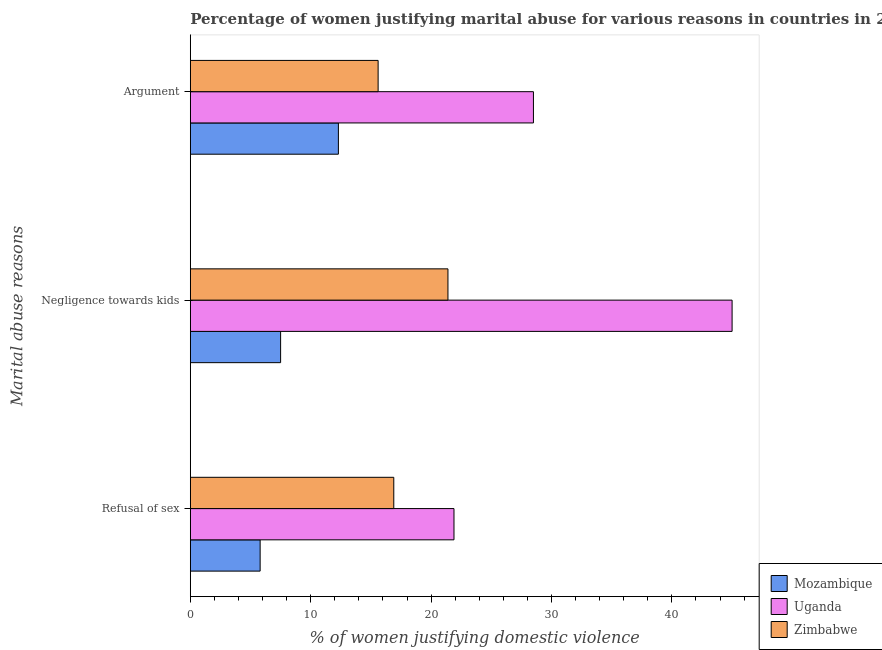Are the number of bars per tick equal to the number of legend labels?
Make the answer very short. Yes. Are the number of bars on each tick of the Y-axis equal?
Your answer should be compact. Yes. How many bars are there on the 3rd tick from the top?
Offer a terse response. 3. How many bars are there on the 3rd tick from the bottom?
Give a very brief answer. 3. What is the label of the 3rd group of bars from the top?
Ensure brevity in your answer.  Refusal of sex. In which country was the percentage of women justifying domestic violence due to refusal of sex maximum?
Your response must be concise. Uganda. In which country was the percentage of women justifying domestic violence due to negligence towards kids minimum?
Your answer should be compact. Mozambique. What is the total percentage of women justifying domestic violence due to arguments in the graph?
Make the answer very short. 56.4. What is the difference between the percentage of women justifying domestic violence due to refusal of sex in Zimbabwe and that in Mozambique?
Offer a very short reply. 11.1. What is the difference between the percentage of women justifying domestic violence due to negligence towards kids in Mozambique and the percentage of women justifying domestic violence due to refusal of sex in Zimbabwe?
Make the answer very short. -9.4. What is the average percentage of women justifying domestic violence due to refusal of sex per country?
Your response must be concise. 14.87. What is the difference between the percentage of women justifying domestic violence due to arguments and percentage of women justifying domestic violence due to refusal of sex in Zimbabwe?
Your response must be concise. -1.3. In how many countries, is the percentage of women justifying domestic violence due to arguments greater than 34 %?
Ensure brevity in your answer.  0. What is the ratio of the percentage of women justifying domestic violence due to negligence towards kids in Uganda to that in Zimbabwe?
Provide a succinct answer. 2.1. Is the percentage of women justifying domestic violence due to negligence towards kids in Zimbabwe less than that in Uganda?
Provide a short and direct response. Yes. Is the difference between the percentage of women justifying domestic violence due to arguments in Uganda and Mozambique greater than the difference between the percentage of women justifying domestic violence due to negligence towards kids in Uganda and Mozambique?
Your answer should be compact. No. What is the difference between the highest and the second highest percentage of women justifying domestic violence due to arguments?
Keep it short and to the point. 12.9. What is the difference between the highest and the lowest percentage of women justifying domestic violence due to negligence towards kids?
Offer a terse response. 37.5. In how many countries, is the percentage of women justifying domestic violence due to refusal of sex greater than the average percentage of women justifying domestic violence due to refusal of sex taken over all countries?
Your answer should be very brief. 2. What does the 2nd bar from the top in Negligence towards kids represents?
Give a very brief answer. Uganda. What does the 1st bar from the bottom in Negligence towards kids represents?
Your answer should be very brief. Mozambique. How many bars are there?
Your answer should be very brief. 9. Are all the bars in the graph horizontal?
Provide a succinct answer. Yes. How many countries are there in the graph?
Your response must be concise. 3. Are the values on the major ticks of X-axis written in scientific E-notation?
Offer a terse response. No. How many legend labels are there?
Make the answer very short. 3. How are the legend labels stacked?
Offer a very short reply. Vertical. What is the title of the graph?
Provide a succinct answer. Percentage of women justifying marital abuse for various reasons in countries in 2011. Does "Senegal" appear as one of the legend labels in the graph?
Provide a succinct answer. No. What is the label or title of the X-axis?
Offer a very short reply. % of women justifying domestic violence. What is the label or title of the Y-axis?
Offer a very short reply. Marital abuse reasons. What is the % of women justifying domestic violence in Uganda in Refusal of sex?
Provide a succinct answer. 21.9. What is the % of women justifying domestic violence in Mozambique in Negligence towards kids?
Offer a very short reply. 7.5. What is the % of women justifying domestic violence in Uganda in Negligence towards kids?
Keep it short and to the point. 45. What is the % of women justifying domestic violence in Zimbabwe in Negligence towards kids?
Offer a very short reply. 21.4. What is the % of women justifying domestic violence in Uganda in Argument?
Your answer should be compact. 28.5. Across all Marital abuse reasons, what is the maximum % of women justifying domestic violence in Mozambique?
Give a very brief answer. 12.3. Across all Marital abuse reasons, what is the maximum % of women justifying domestic violence of Zimbabwe?
Ensure brevity in your answer.  21.4. Across all Marital abuse reasons, what is the minimum % of women justifying domestic violence of Uganda?
Provide a short and direct response. 21.9. What is the total % of women justifying domestic violence in Mozambique in the graph?
Your answer should be compact. 25.6. What is the total % of women justifying domestic violence in Uganda in the graph?
Provide a short and direct response. 95.4. What is the total % of women justifying domestic violence in Zimbabwe in the graph?
Offer a very short reply. 53.9. What is the difference between the % of women justifying domestic violence in Mozambique in Refusal of sex and that in Negligence towards kids?
Give a very brief answer. -1.7. What is the difference between the % of women justifying domestic violence of Uganda in Refusal of sex and that in Negligence towards kids?
Make the answer very short. -23.1. What is the difference between the % of women justifying domestic violence in Zimbabwe in Refusal of sex and that in Negligence towards kids?
Your answer should be very brief. -4.5. What is the difference between the % of women justifying domestic violence in Uganda in Refusal of sex and that in Argument?
Give a very brief answer. -6.6. What is the difference between the % of women justifying domestic violence of Zimbabwe in Refusal of sex and that in Argument?
Give a very brief answer. 1.3. What is the difference between the % of women justifying domestic violence in Mozambique in Negligence towards kids and that in Argument?
Give a very brief answer. -4.8. What is the difference between the % of women justifying domestic violence of Mozambique in Refusal of sex and the % of women justifying domestic violence of Uganda in Negligence towards kids?
Your response must be concise. -39.2. What is the difference between the % of women justifying domestic violence of Mozambique in Refusal of sex and the % of women justifying domestic violence of Zimbabwe in Negligence towards kids?
Provide a succinct answer. -15.6. What is the difference between the % of women justifying domestic violence of Mozambique in Refusal of sex and the % of women justifying domestic violence of Uganda in Argument?
Your response must be concise. -22.7. What is the difference between the % of women justifying domestic violence in Uganda in Refusal of sex and the % of women justifying domestic violence in Zimbabwe in Argument?
Your answer should be compact. 6.3. What is the difference between the % of women justifying domestic violence of Mozambique in Negligence towards kids and the % of women justifying domestic violence of Zimbabwe in Argument?
Provide a short and direct response. -8.1. What is the difference between the % of women justifying domestic violence in Uganda in Negligence towards kids and the % of women justifying domestic violence in Zimbabwe in Argument?
Keep it short and to the point. 29.4. What is the average % of women justifying domestic violence in Mozambique per Marital abuse reasons?
Ensure brevity in your answer.  8.53. What is the average % of women justifying domestic violence in Uganda per Marital abuse reasons?
Give a very brief answer. 31.8. What is the average % of women justifying domestic violence of Zimbabwe per Marital abuse reasons?
Keep it short and to the point. 17.97. What is the difference between the % of women justifying domestic violence of Mozambique and % of women justifying domestic violence of Uganda in Refusal of sex?
Give a very brief answer. -16.1. What is the difference between the % of women justifying domestic violence of Mozambique and % of women justifying domestic violence of Zimbabwe in Refusal of sex?
Your answer should be very brief. -11.1. What is the difference between the % of women justifying domestic violence in Uganda and % of women justifying domestic violence in Zimbabwe in Refusal of sex?
Offer a very short reply. 5. What is the difference between the % of women justifying domestic violence of Mozambique and % of women justifying domestic violence of Uganda in Negligence towards kids?
Your response must be concise. -37.5. What is the difference between the % of women justifying domestic violence in Uganda and % of women justifying domestic violence in Zimbabwe in Negligence towards kids?
Your answer should be very brief. 23.6. What is the difference between the % of women justifying domestic violence in Mozambique and % of women justifying domestic violence in Uganda in Argument?
Make the answer very short. -16.2. What is the ratio of the % of women justifying domestic violence in Mozambique in Refusal of sex to that in Negligence towards kids?
Keep it short and to the point. 0.77. What is the ratio of the % of women justifying domestic violence of Uganda in Refusal of sex to that in Negligence towards kids?
Give a very brief answer. 0.49. What is the ratio of the % of women justifying domestic violence of Zimbabwe in Refusal of sex to that in Negligence towards kids?
Ensure brevity in your answer.  0.79. What is the ratio of the % of women justifying domestic violence in Mozambique in Refusal of sex to that in Argument?
Keep it short and to the point. 0.47. What is the ratio of the % of women justifying domestic violence in Uganda in Refusal of sex to that in Argument?
Ensure brevity in your answer.  0.77. What is the ratio of the % of women justifying domestic violence in Zimbabwe in Refusal of sex to that in Argument?
Provide a short and direct response. 1.08. What is the ratio of the % of women justifying domestic violence of Mozambique in Negligence towards kids to that in Argument?
Provide a succinct answer. 0.61. What is the ratio of the % of women justifying domestic violence of Uganda in Negligence towards kids to that in Argument?
Make the answer very short. 1.58. What is the ratio of the % of women justifying domestic violence of Zimbabwe in Negligence towards kids to that in Argument?
Give a very brief answer. 1.37. What is the difference between the highest and the lowest % of women justifying domestic violence in Mozambique?
Make the answer very short. 6.5. What is the difference between the highest and the lowest % of women justifying domestic violence in Uganda?
Your response must be concise. 23.1. 